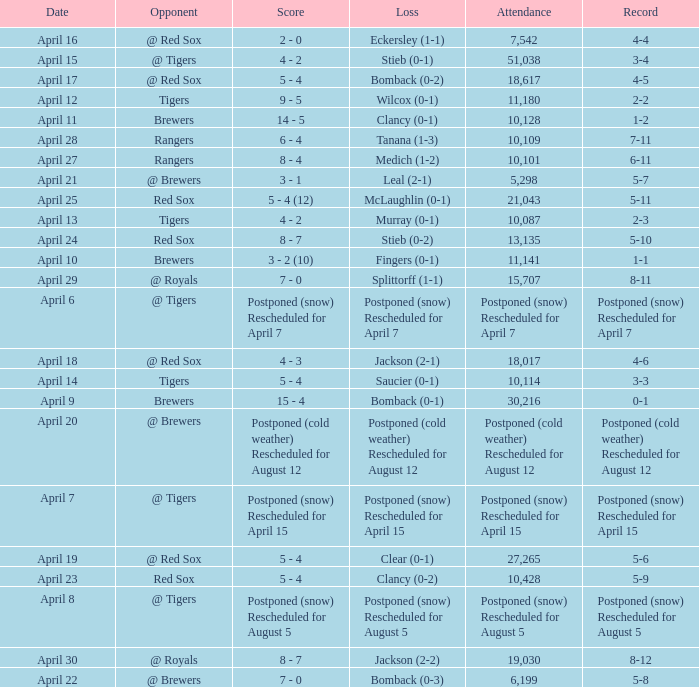Which record is dated April 8? Postponed (snow) Rescheduled for August 5. 